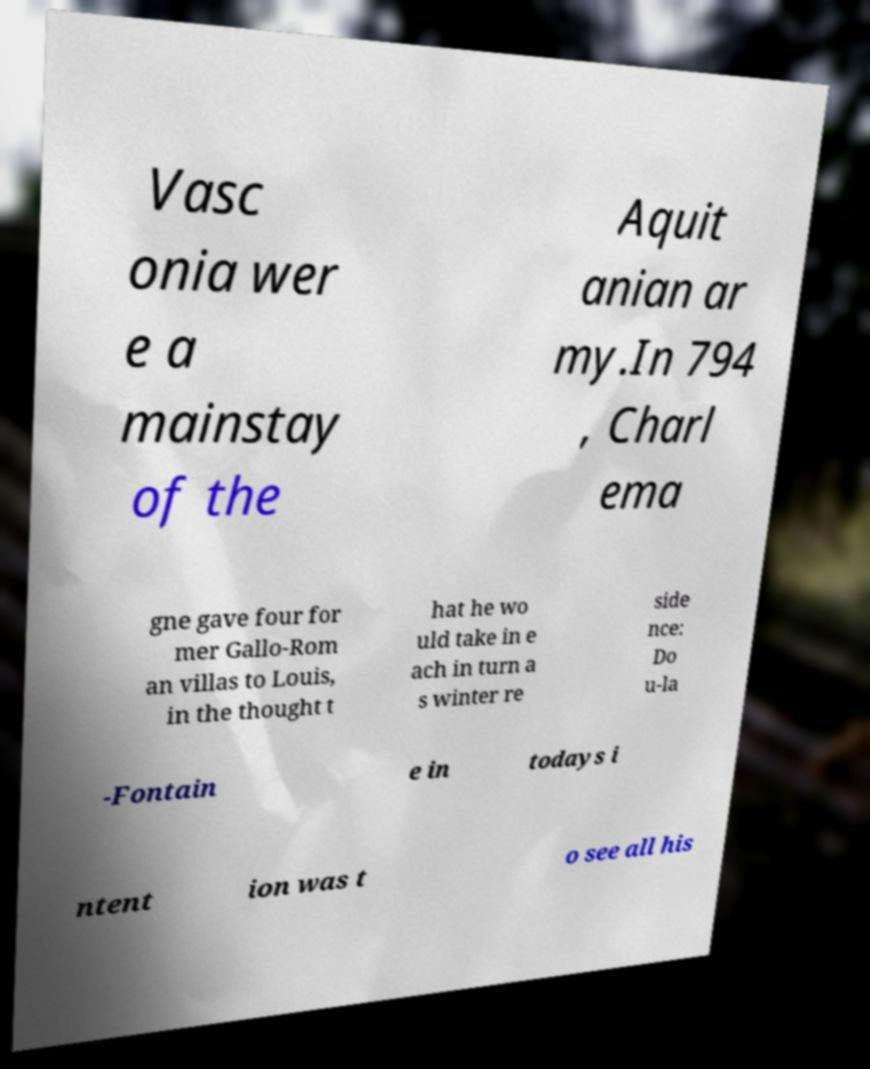Please identify and transcribe the text found in this image. Vasc onia wer e a mainstay of the Aquit anian ar my.In 794 , Charl ema gne gave four for mer Gallo-Rom an villas to Louis, in the thought t hat he wo uld take in e ach in turn a s winter re side nce: Do u-la -Fontain e in todays i ntent ion was t o see all his 